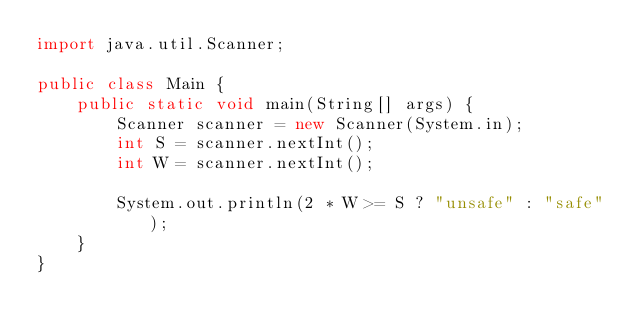<code> <loc_0><loc_0><loc_500><loc_500><_Java_>import java.util.Scanner;

public class Main {
    public static void main(String[] args) {
        Scanner scanner = new Scanner(System.in);
        int S = scanner.nextInt();
        int W = scanner.nextInt();

        System.out.println(2 * W >= S ? "unsafe" : "safe");
    }
}</code> 